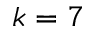<formula> <loc_0><loc_0><loc_500><loc_500>k = 7</formula> 